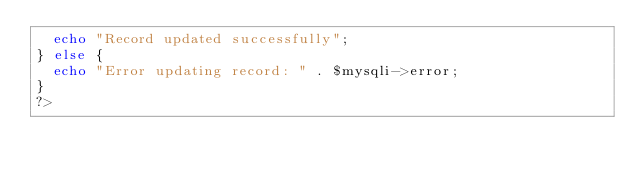Convert code to text. <code><loc_0><loc_0><loc_500><loc_500><_PHP_>  echo "Record updated successfully";
} else {
  echo "Error updating record: " . $mysqli->error;
}
?></code> 